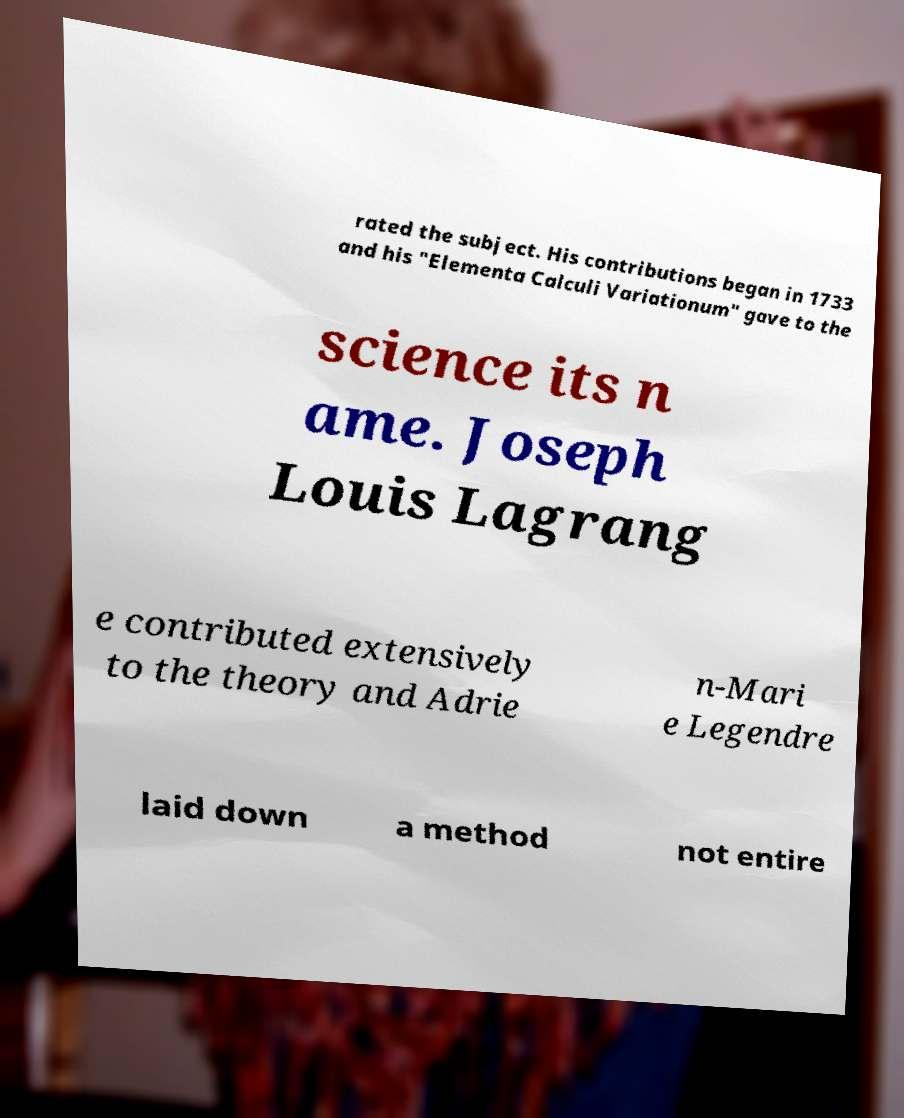Please identify and transcribe the text found in this image. rated the subject. His contributions began in 1733 and his "Elementa Calculi Variationum" gave to the science its n ame. Joseph Louis Lagrang e contributed extensively to the theory and Adrie n-Mari e Legendre laid down a method not entire 